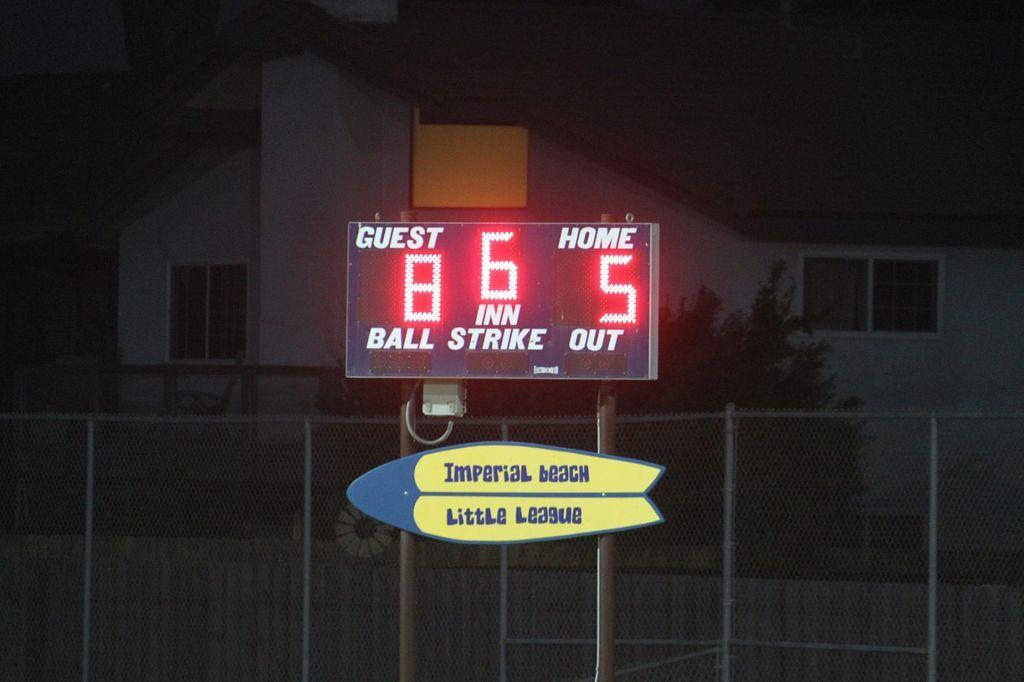Can you describe this image briefly? In the foreground there are two boards attached to the two poles. On the boards I can see some text and lights. At the back of it there is a net fencing. In the background, I can see a building in the dark. 